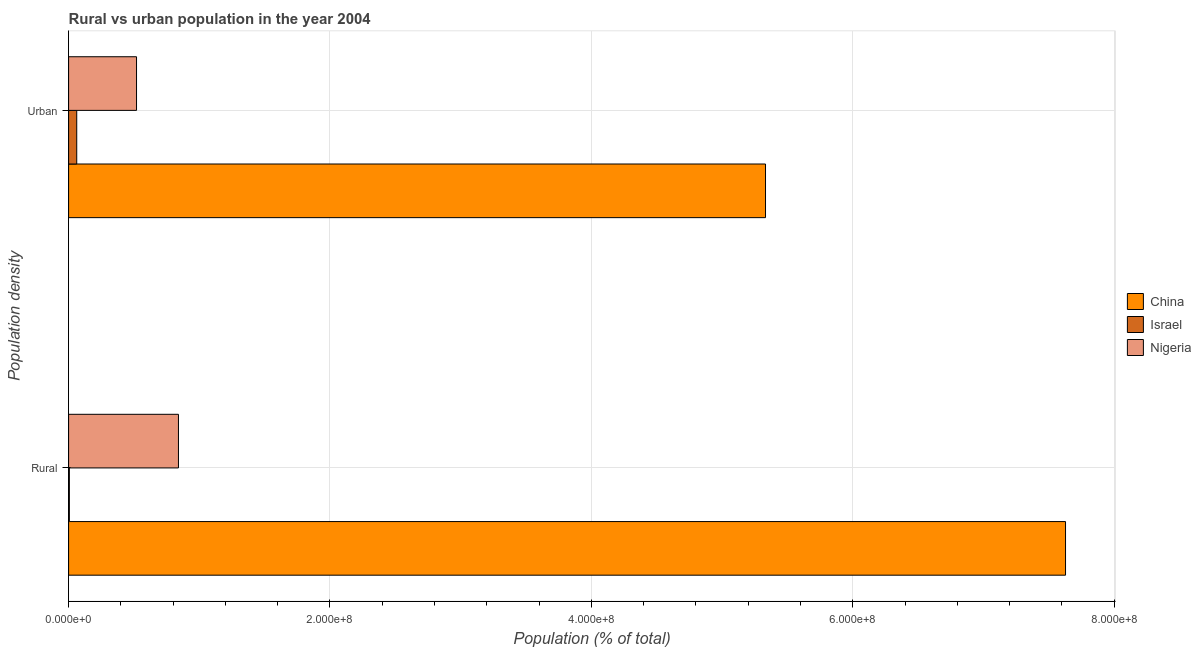How many groups of bars are there?
Ensure brevity in your answer.  2. Are the number of bars on each tick of the Y-axis equal?
Your response must be concise. Yes. How many bars are there on the 2nd tick from the top?
Your answer should be compact. 3. How many bars are there on the 1st tick from the bottom?
Your answer should be compact. 3. What is the label of the 1st group of bars from the top?
Your answer should be compact. Urban. What is the urban population density in China?
Your answer should be compact. 5.33e+08. Across all countries, what is the maximum urban population density?
Make the answer very short. 5.33e+08. Across all countries, what is the minimum urban population density?
Your response must be concise. 6.23e+06. In which country was the rural population density maximum?
Your response must be concise. China. What is the total urban population density in the graph?
Keep it short and to the point. 5.91e+08. What is the difference between the urban population density in Israel and that in Nigeria?
Your answer should be compact. -4.58e+07. What is the difference between the rural population density in Israel and the urban population density in Nigeria?
Offer a terse response. -5.14e+07. What is the average urban population density per country?
Your answer should be compact. 1.97e+08. What is the difference between the urban population density and rural population density in Israel?
Your response must be concise. 5.65e+06. In how many countries, is the rural population density greater than 360000000 %?
Offer a very short reply. 1. What is the ratio of the rural population density in Israel to that in China?
Offer a very short reply. 0. In how many countries, is the urban population density greater than the average urban population density taken over all countries?
Your answer should be very brief. 1. Does the graph contain any zero values?
Ensure brevity in your answer.  No. Where does the legend appear in the graph?
Ensure brevity in your answer.  Center right. How many legend labels are there?
Your answer should be compact. 3. How are the legend labels stacked?
Offer a terse response. Vertical. What is the title of the graph?
Offer a very short reply. Rural vs urban population in the year 2004. Does "Panama" appear as one of the legend labels in the graph?
Provide a short and direct response. No. What is the label or title of the X-axis?
Your response must be concise. Population (% of total). What is the label or title of the Y-axis?
Keep it short and to the point. Population density. What is the Population (% of total) in China in Rural?
Your answer should be compact. 7.63e+08. What is the Population (% of total) of Israel in Rural?
Ensure brevity in your answer.  5.82e+05. What is the Population (% of total) of Nigeria in Rural?
Your answer should be compact. 8.41e+07. What is the Population (% of total) of China in Urban?
Offer a terse response. 5.33e+08. What is the Population (% of total) in Israel in Urban?
Keep it short and to the point. 6.23e+06. What is the Population (% of total) in Nigeria in Urban?
Your answer should be compact. 5.20e+07. Across all Population density, what is the maximum Population (% of total) in China?
Provide a short and direct response. 7.63e+08. Across all Population density, what is the maximum Population (% of total) of Israel?
Your response must be concise. 6.23e+06. Across all Population density, what is the maximum Population (% of total) in Nigeria?
Offer a terse response. 8.41e+07. Across all Population density, what is the minimum Population (% of total) of China?
Provide a short and direct response. 5.33e+08. Across all Population density, what is the minimum Population (% of total) in Israel?
Provide a succinct answer. 5.82e+05. Across all Population density, what is the minimum Population (% of total) in Nigeria?
Offer a terse response. 5.20e+07. What is the total Population (% of total) in China in the graph?
Your answer should be compact. 1.30e+09. What is the total Population (% of total) in Israel in the graph?
Offer a terse response. 6.81e+06. What is the total Population (% of total) in Nigeria in the graph?
Your answer should be very brief. 1.36e+08. What is the difference between the Population (% of total) of China in Rural and that in Urban?
Provide a short and direct response. 2.30e+08. What is the difference between the Population (% of total) in Israel in Rural and that in Urban?
Your response must be concise. -5.65e+06. What is the difference between the Population (% of total) in Nigeria in Rural and that in Urban?
Your answer should be compact. 3.21e+07. What is the difference between the Population (% of total) of China in Rural and the Population (% of total) of Israel in Urban?
Your response must be concise. 7.57e+08. What is the difference between the Population (% of total) of China in Rural and the Population (% of total) of Nigeria in Urban?
Make the answer very short. 7.11e+08. What is the difference between the Population (% of total) of Israel in Rural and the Population (% of total) of Nigeria in Urban?
Ensure brevity in your answer.  -5.14e+07. What is the average Population (% of total) of China per Population density?
Give a very brief answer. 6.48e+08. What is the average Population (% of total) of Israel per Population density?
Provide a succinct answer. 3.40e+06. What is the average Population (% of total) in Nigeria per Population density?
Ensure brevity in your answer.  6.80e+07. What is the difference between the Population (% of total) of China and Population (% of total) of Israel in Rural?
Ensure brevity in your answer.  7.62e+08. What is the difference between the Population (% of total) in China and Population (% of total) in Nigeria in Rural?
Ensure brevity in your answer.  6.79e+08. What is the difference between the Population (% of total) in Israel and Population (% of total) in Nigeria in Rural?
Your answer should be compact. -8.35e+07. What is the difference between the Population (% of total) in China and Population (% of total) in Israel in Urban?
Provide a succinct answer. 5.27e+08. What is the difference between the Population (% of total) in China and Population (% of total) in Nigeria in Urban?
Your response must be concise. 4.81e+08. What is the difference between the Population (% of total) in Israel and Population (% of total) in Nigeria in Urban?
Provide a succinct answer. -4.58e+07. What is the ratio of the Population (% of total) of China in Rural to that in Urban?
Your answer should be compact. 1.43. What is the ratio of the Population (% of total) in Israel in Rural to that in Urban?
Offer a terse response. 0.09. What is the ratio of the Population (% of total) of Nigeria in Rural to that in Urban?
Keep it short and to the point. 1.62. What is the difference between the highest and the second highest Population (% of total) in China?
Offer a very short reply. 2.30e+08. What is the difference between the highest and the second highest Population (% of total) in Israel?
Your answer should be compact. 5.65e+06. What is the difference between the highest and the second highest Population (% of total) of Nigeria?
Give a very brief answer. 3.21e+07. What is the difference between the highest and the lowest Population (% of total) in China?
Offer a terse response. 2.30e+08. What is the difference between the highest and the lowest Population (% of total) of Israel?
Provide a short and direct response. 5.65e+06. What is the difference between the highest and the lowest Population (% of total) in Nigeria?
Provide a succinct answer. 3.21e+07. 